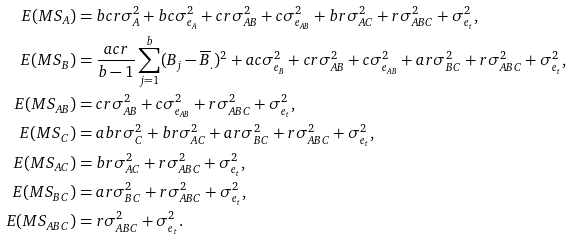Convert formula to latex. <formula><loc_0><loc_0><loc_500><loc_500>E ( M S _ { A } ) & = b c r \sigma _ { A } ^ { 2 } + b c \sigma _ { e _ { A } } ^ { 2 } + c r \sigma _ { A B } ^ { 2 } + c \sigma _ { e _ { A B } } ^ { 2 } + b r \sigma _ { A C } ^ { 2 } + r \sigma _ { A B C } ^ { 2 } + \sigma _ { e _ { t } } ^ { 2 } , \\ E ( M S _ { B } ) & = \frac { a c r } { b - 1 } \sum _ { j = 1 } ^ { b } ( B _ { j } - \overline { B } _ { . } ) ^ { 2 } + a c \sigma _ { e _ { B } } ^ { 2 } + c r \sigma _ { A B } ^ { 2 } + c \sigma _ { e _ { A B } } ^ { 2 } + a r \sigma _ { B C } ^ { 2 } + r \sigma _ { A B C } ^ { 2 } + \sigma _ { e _ { t } } ^ { 2 } , \\ E ( M S _ { A B } ) & = c r \sigma _ { A B } ^ { 2 } + c \sigma _ { e _ { A B } } ^ { 2 } + r \sigma _ { A B C } ^ { 2 } + \sigma _ { e _ { t } } ^ { 2 } , \\ E ( M S _ { C } ) & = a b r \sigma _ { C } ^ { 2 } + b r \sigma _ { A C } ^ { 2 } + a r \sigma _ { B C } ^ { 2 } + r \sigma _ { A B C } ^ { 2 } + \sigma _ { e _ { t } } ^ { 2 } , \\ E ( M S _ { A C } ) & = b r \sigma _ { A C } ^ { 2 } + r \sigma _ { A B C } ^ { 2 } + \sigma _ { e _ { t } } ^ { 2 } , \\ E ( M S _ { B C } ) & = a r \sigma _ { B C } ^ { 2 } + r \sigma _ { A B C } ^ { 2 } + \sigma _ { e _ { t } } ^ { 2 } , \\ E ( M S _ { A B C } ) & = r \sigma _ { A B C } ^ { 2 } + \sigma _ { e _ { t } } ^ { 2 } .</formula> 